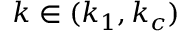Convert formula to latex. <formula><loc_0><loc_0><loc_500><loc_500>k \in ( k _ { 1 } , k _ { c } )</formula> 